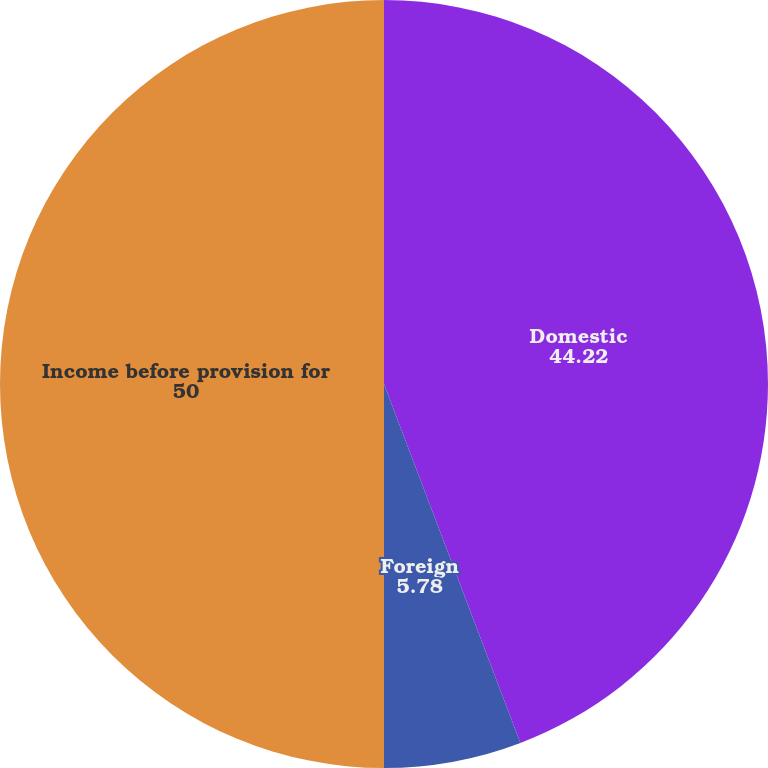Convert chart. <chart><loc_0><loc_0><loc_500><loc_500><pie_chart><fcel>Domestic<fcel>Foreign<fcel>Income before provision for<nl><fcel>44.22%<fcel>5.78%<fcel>50.0%<nl></chart> 